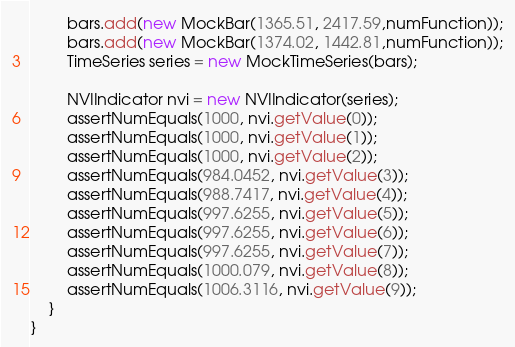Convert code to text. <code><loc_0><loc_0><loc_500><loc_500><_Java_>        bars.add(new MockBar(1365.51, 2417.59,numFunction));
        bars.add(new MockBar(1374.02, 1442.81,numFunction));
        TimeSeries series = new MockTimeSeries(bars);

        NVIIndicator nvi = new NVIIndicator(series);
        assertNumEquals(1000, nvi.getValue(0));
        assertNumEquals(1000, nvi.getValue(1));
        assertNumEquals(1000, nvi.getValue(2));
        assertNumEquals(984.0452, nvi.getValue(3));
        assertNumEquals(988.7417, nvi.getValue(4));
        assertNumEquals(997.6255, nvi.getValue(5));
        assertNumEquals(997.6255, nvi.getValue(6));
        assertNumEquals(997.6255, nvi.getValue(7));
        assertNumEquals(1000.079, nvi.getValue(8));
        assertNumEquals(1006.3116, nvi.getValue(9));
    }
}
</code> 